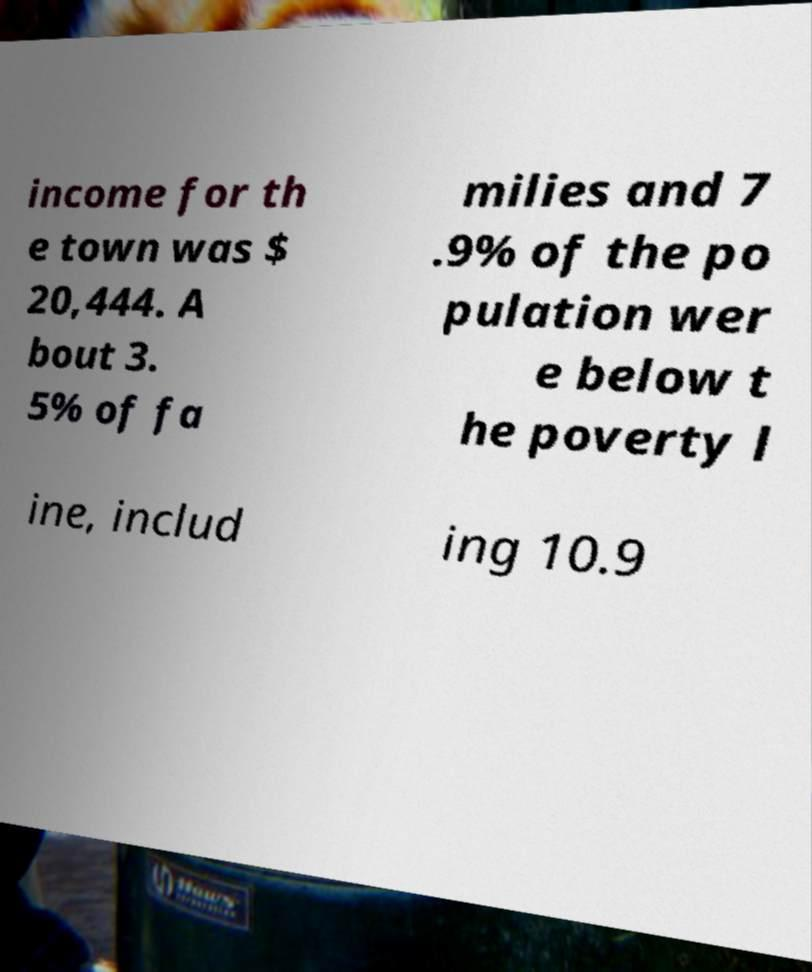I need the written content from this picture converted into text. Can you do that? income for th e town was $ 20,444. A bout 3. 5% of fa milies and 7 .9% of the po pulation wer e below t he poverty l ine, includ ing 10.9 